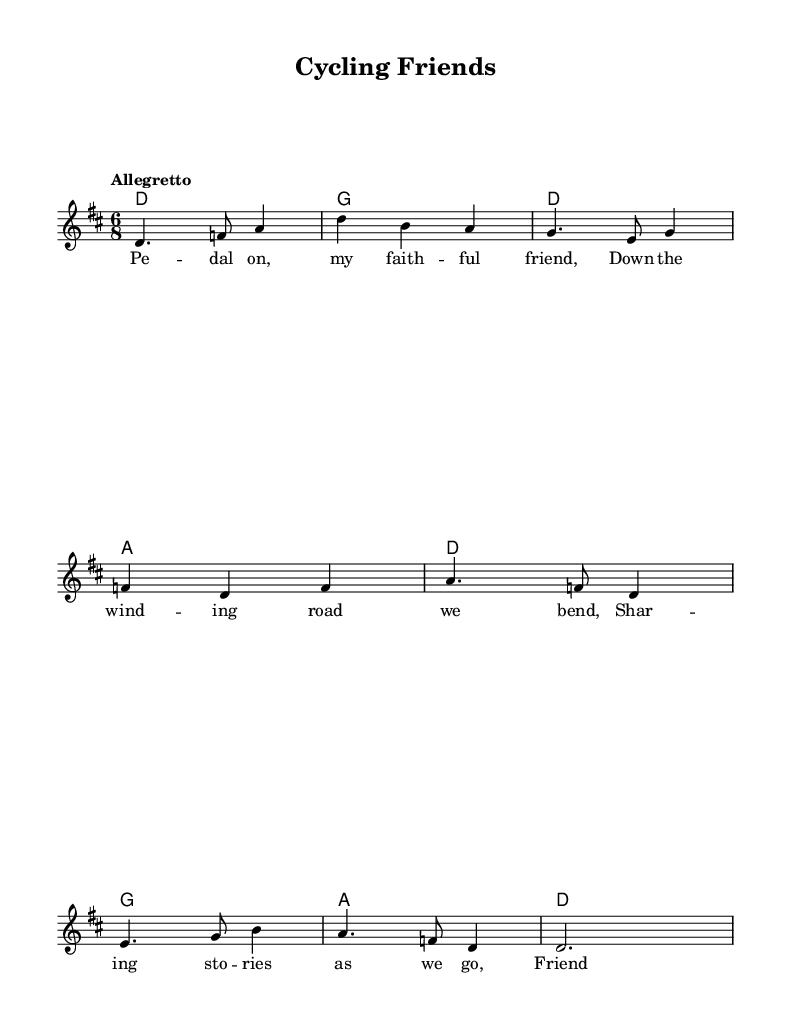What is the key signature of this music? The key signature indicates two sharps, which correspond to F# and C#. This is typical of D major, as it accommodates the major scale spanning from D to D.
Answer: D major What is the time signature of this music? The time signature is displayed at the beginning of the score, showing a 6 over 8, which indicates six eighth notes per measure, typical for a lively dance or folk piece.
Answer: 6/8 What is the tempo marking of this music? The tempo is indicated with the word "Allegretto," suggesting a moderately fast pace, commonly used in folk and traditional music to create a cheerful atmosphere.
Answer: Allegretto What is the theme of the lyrics in the first verse? The lyrics emphasize friendship and camaraderie, suggesting a journey shared between friends, highlighting strong bonds and shared experiences throughout life.
Answer: Friendship How many measures are in the melody section? By counting the distinct groupings of notes, we see there are eight measures in total; each grouping is defined visually by bar lines throughout the melody section of the music.
Answer: Eight What musical element is represented by the chord names in the score? The chord names are shown above the melody and represent the harmonization; they indicate the underlying harmonic structure, supporting the melody with chords like D, G, and A.
Answer: Chord names What type of song is represented in this music? The composition is a traditional Irish folk song, characterized by its storytelling nature, focus on camaraderie, and its cultural roots.
Answer: Traditional Irish folk song 